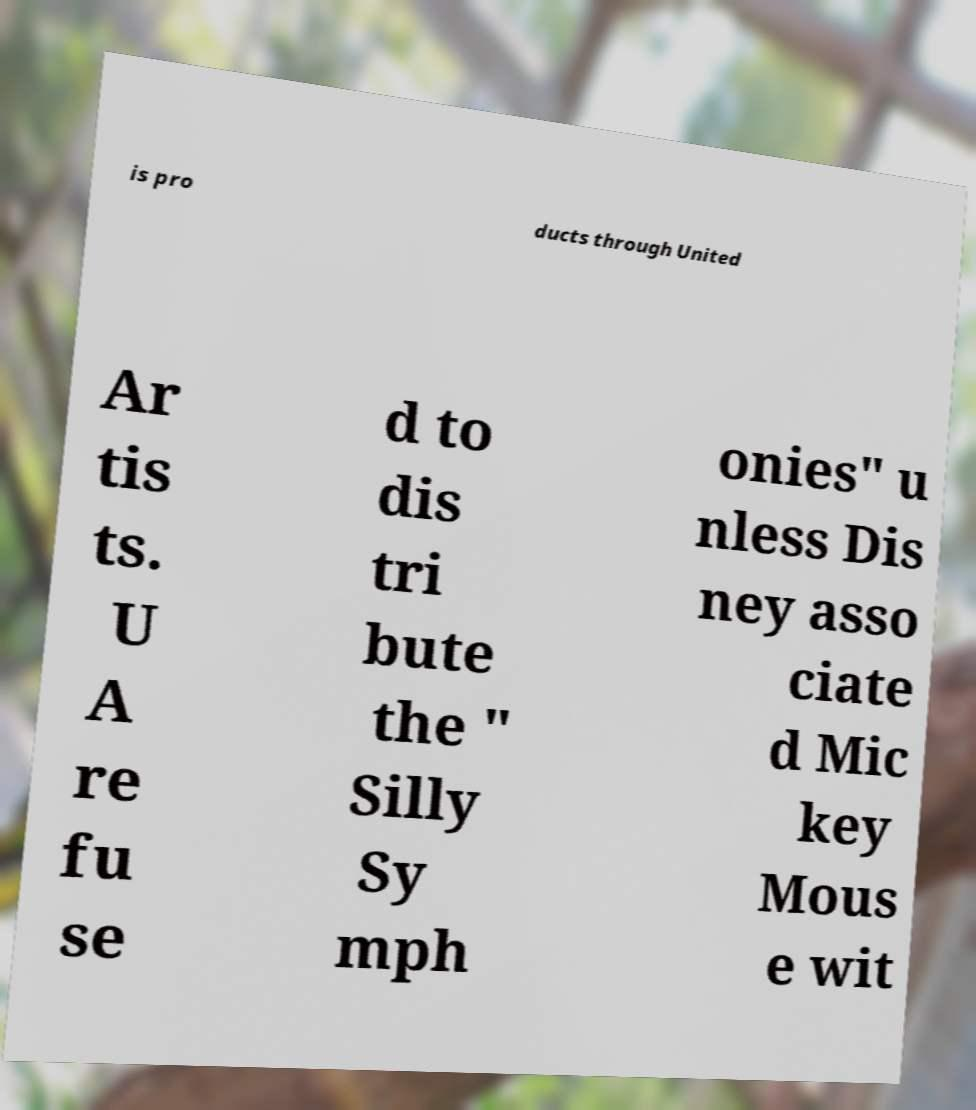Please read and relay the text visible in this image. What does it say? is pro ducts through United Ar tis ts. U A re fu se d to dis tri bute the " Silly Sy mph onies" u nless Dis ney asso ciate d Mic key Mous e wit 